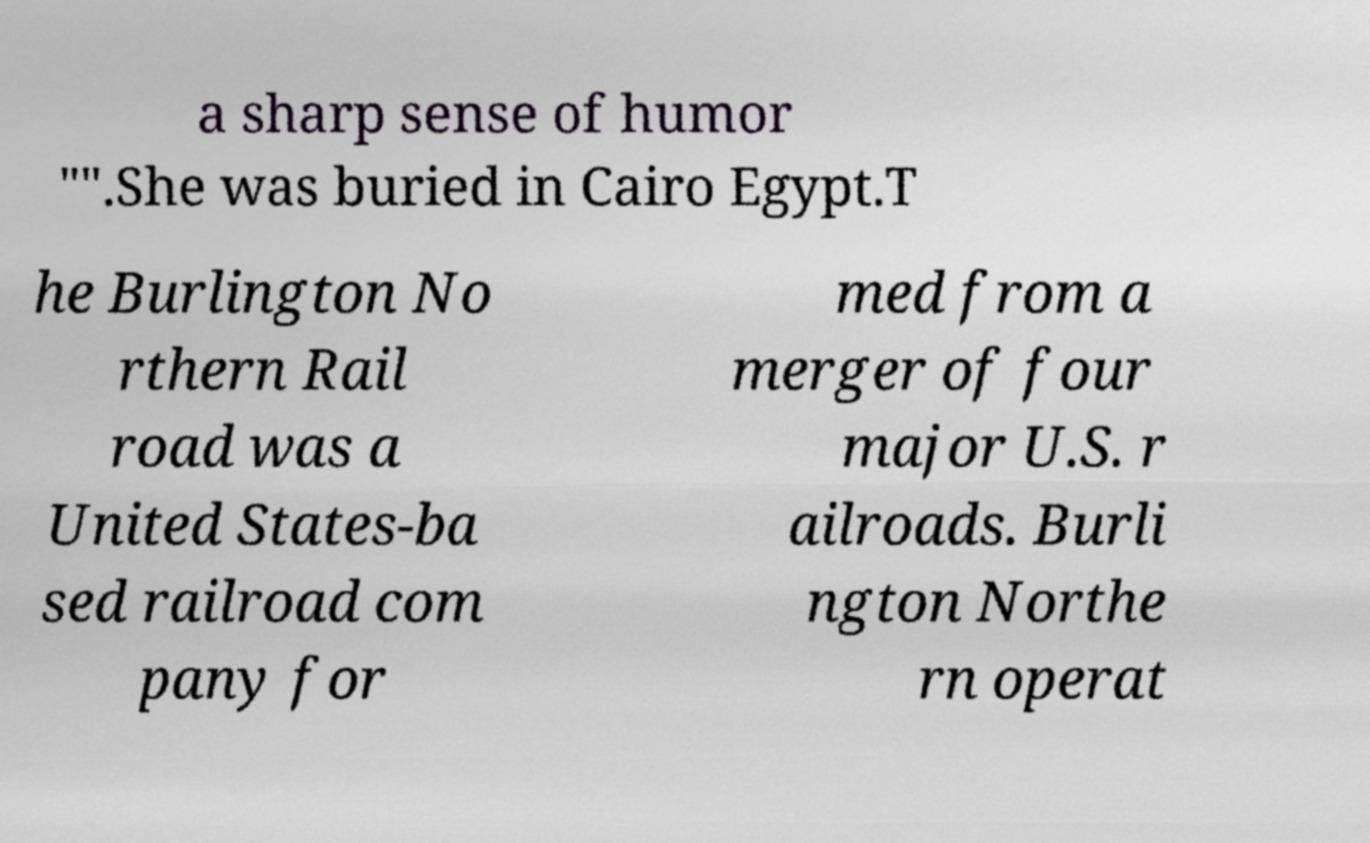Could you assist in decoding the text presented in this image and type it out clearly? a sharp sense of humor "".She was buried in Cairo Egypt.T he Burlington No rthern Rail road was a United States-ba sed railroad com pany for med from a merger of four major U.S. r ailroads. Burli ngton Northe rn operat 